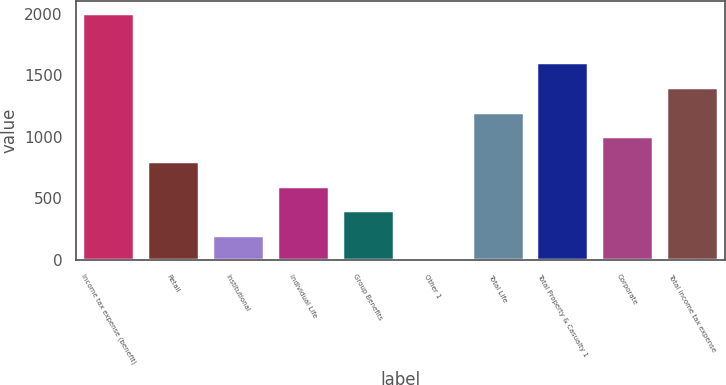<chart> <loc_0><loc_0><loc_500><loc_500><bar_chart><fcel>Income tax expense (benefit)<fcel>Retail<fcel>Institutional<fcel>Individual Life<fcel>Group Benefits<fcel>Other 1<fcel>Total Life<fcel>Total Property & Casualty 1<fcel>Corporate<fcel>Total income tax expense<nl><fcel>2003<fcel>803.6<fcel>203.9<fcel>603.7<fcel>403.8<fcel>4<fcel>1203.4<fcel>1603.2<fcel>1003.5<fcel>1403.3<nl></chart> 